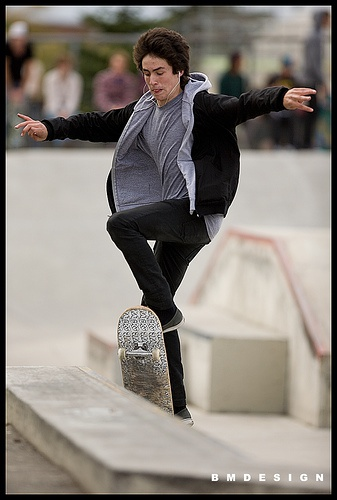Describe the objects in this image and their specific colors. I can see people in black, gray, darkgray, and brown tones, skateboard in black, gray, darkgray, and lightgray tones, people in black, darkgray, and gray tones, people in black, brown, gray, and maroon tones, and people in black, gray, and maroon tones in this image. 